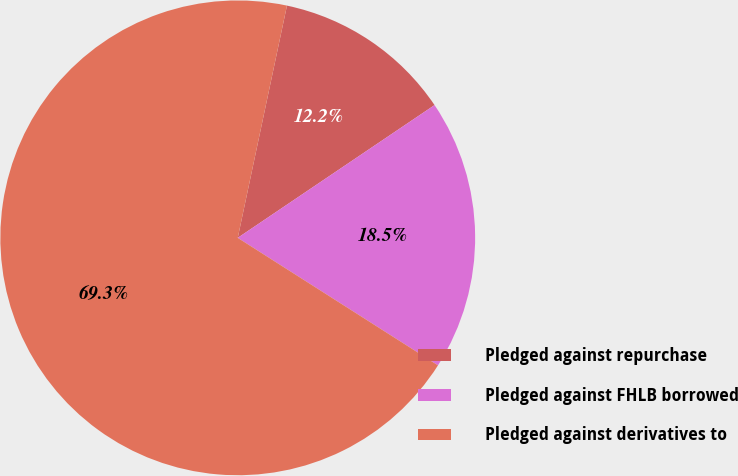Convert chart. <chart><loc_0><loc_0><loc_500><loc_500><pie_chart><fcel>Pledged against repurchase<fcel>Pledged against FHLB borrowed<fcel>Pledged against derivatives to<nl><fcel>12.23%<fcel>18.47%<fcel>69.3%<nl></chart> 